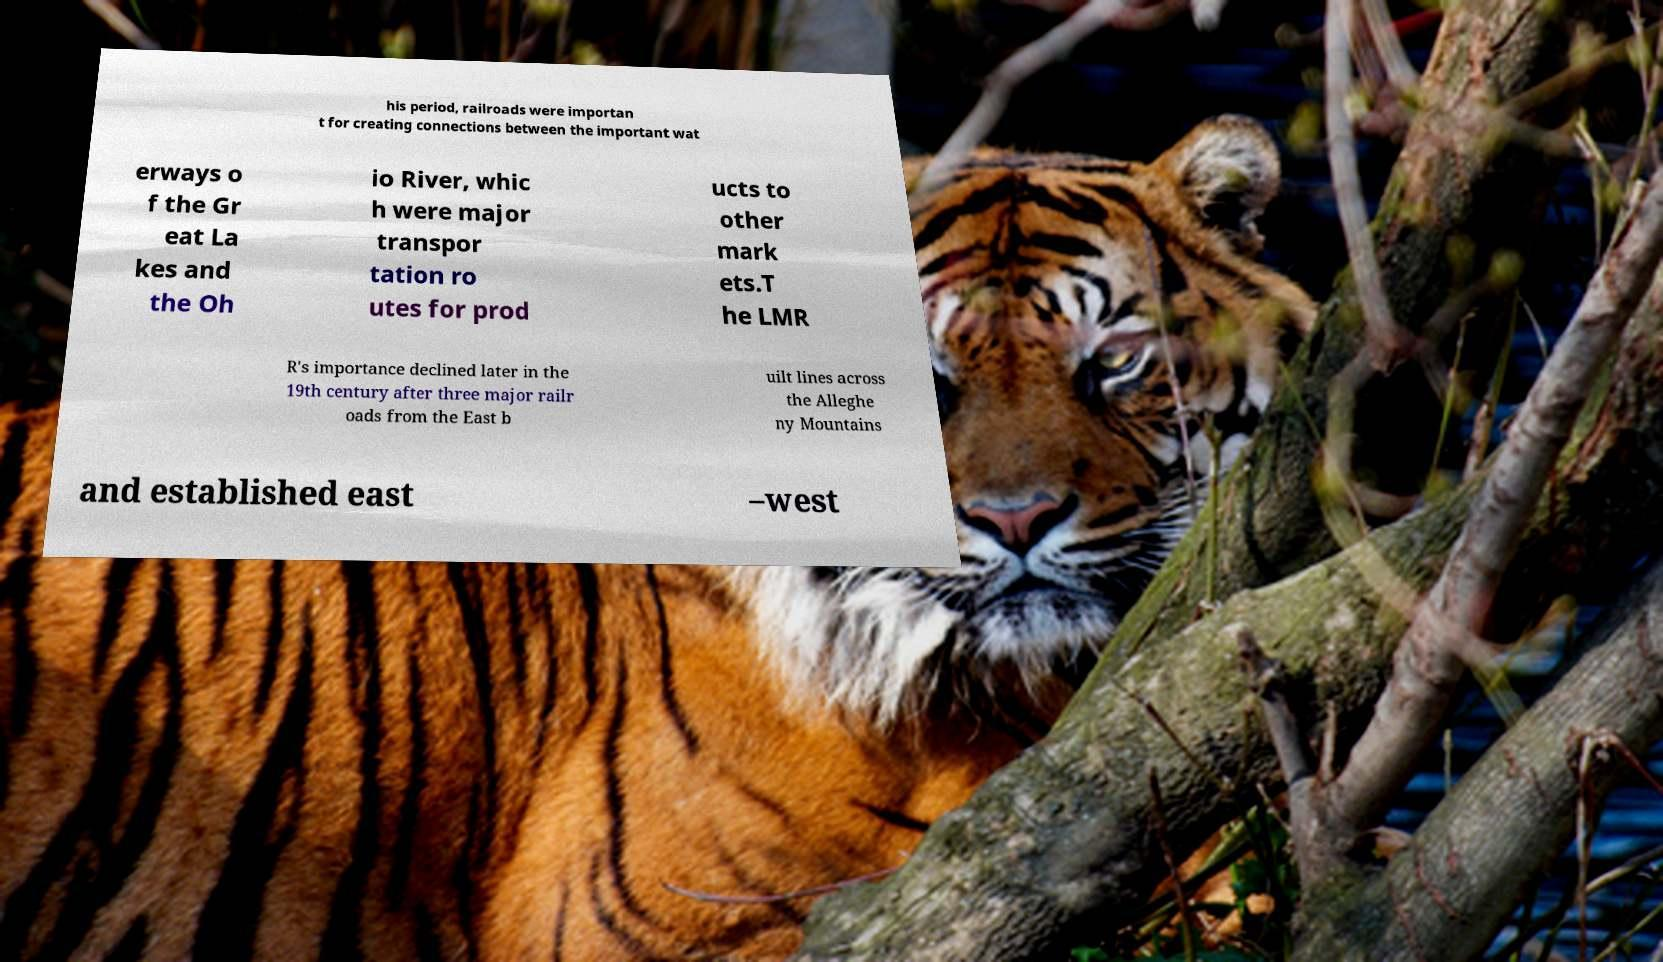Please read and relay the text visible in this image. What does it say? his period, railroads were importan t for creating connections between the important wat erways o f the Gr eat La kes and the Oh io River, whic h were major transpor tation ro utes for prod ucts to other mark ets.T he LMR R's importance declined later in the 19th century after three major railr oads from the East b uilt lines across the Alleghe ny Mountains and established east –west 